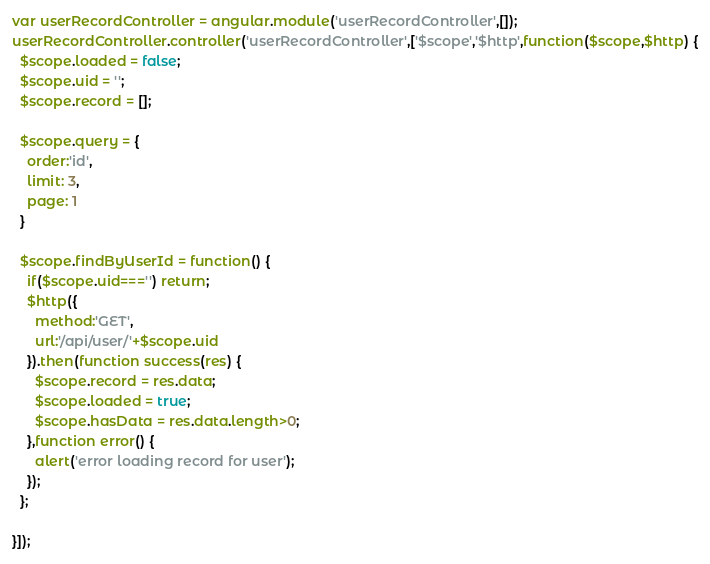<code> <loc_0><loc_0><loc_500><loc_500><_JavaScript_>var userRecordController = angular.module('userRecordController',[]);
userRecordController.controller('userRecordController',['$scope','$http',function($scope,$http) {
  $scope.loaded = false;
  $scope.uid = '';
  $scope.record = [];

  $scope.query = {
    order:'id',
    limit: 3,
    page: 1
  }

  $scope.findByUserId = function() {
    if($scope.uid==='') return;
    $http({
      method:'GET',
      url:'/api/user/'+$scope.uid
    }).then(function success(res) {
      $scope.record = res.data;
      $scope.loaded = true;
      $scope.hasData = res.data.length>0;
    },function error() {
      alert('error loading record for user');
    });
  };

}]);
</code> 